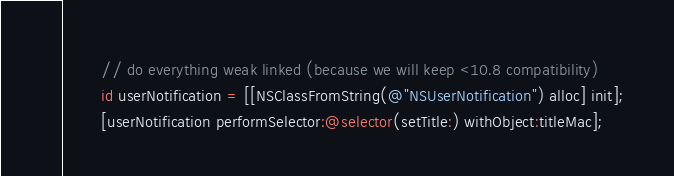Convert code to text. <code><loc_0><loc_0><loc_500><loc_500><_ObjectiveC_>        // do everything weak linked (because we will keep <10.8 compatibility)
        id userNotification = [[NSClassFromString(@"NSUserNotification") alloc] init];
        [userNotification performSelector:@selector(setTitle:) withObject:titleMac];</code> 